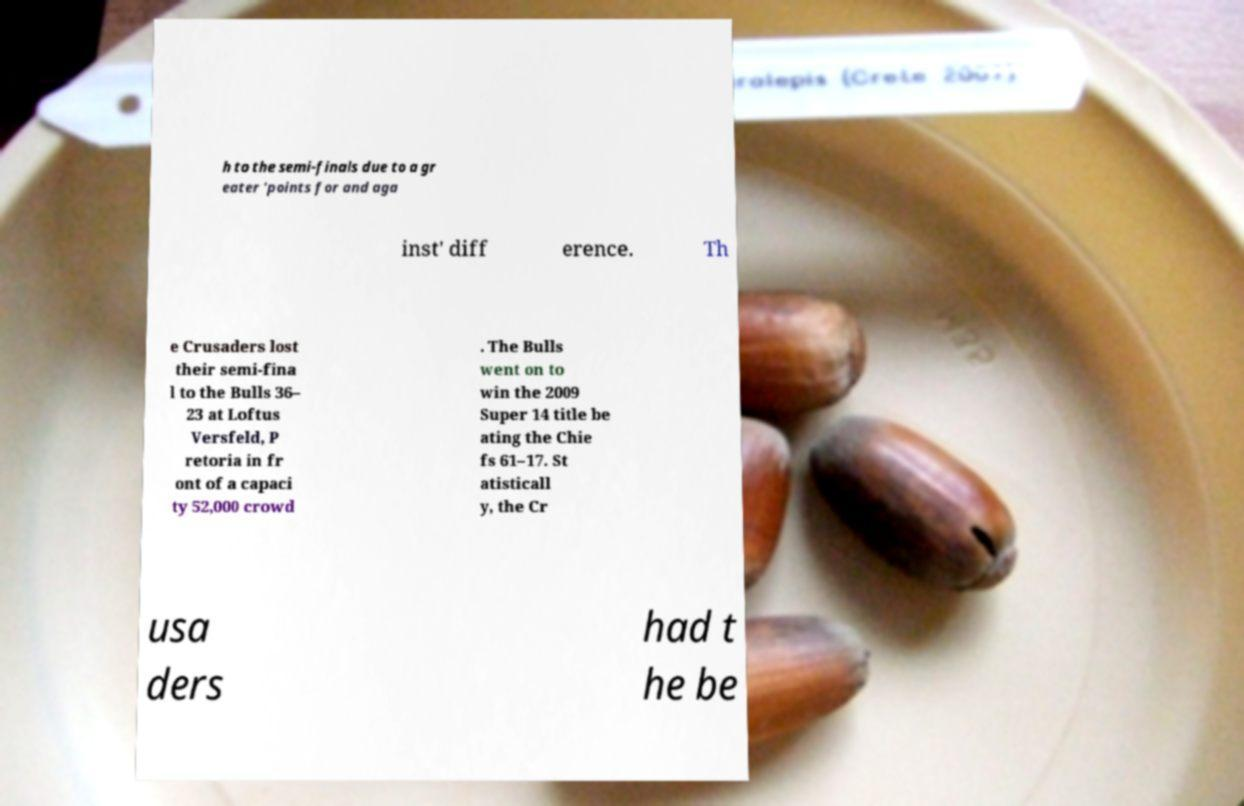Could you extract and type out the text from this image? h to the semi-finals due to a gr eater 'points for and aga inst' diff erence. Th e Crusaders lost their semi-fina l to the Bulls 36– 23 at Loftus Versfeld, P retoria in fr ont of a capaci ty 52,000 crowd . The Bulls went on to win the 2009 Super 14 title be ating the Chie fs 61–17. St atisticall y, the Cr usa ders had t he be 